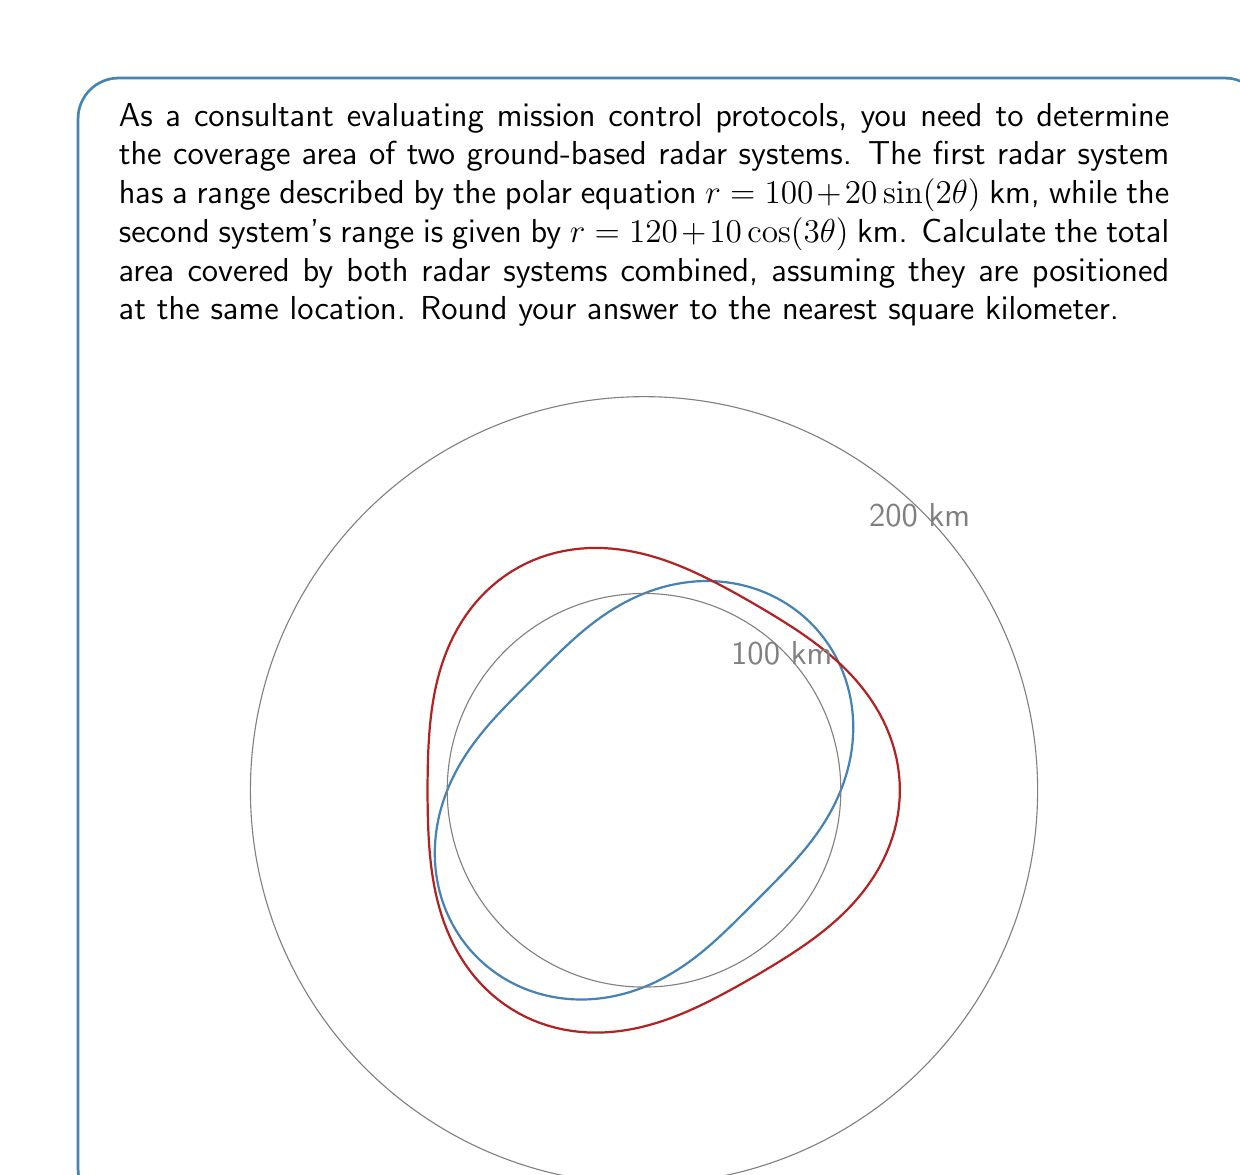Solve this math problem. To solve this problem, we need to calculate the areas of both radar systems and add them together. Let's break it down step-by-step:

1) For a polar equation $r = f(\theta)$, the area is given by the formula:

   $$A = \frac{1}{2} \int_0^{2\pi} [f(\theta)]^2 d\theta$$

2) For the first radar system: $r_1 = 100 + 20\sin(2\theta)$
   Area $A_1 = \frac{1}{2} \int_0^{2\pi} (100 + 20\sin(2\theta))^2 d\theta$

3) Expanding the integrand:
   $(100 + 20\sin(2\theta))^2 = 10000 + 4000\sin(2\theta) + 400\sin^2(2\theta)$

4) Using the identity $\sin^2(2\theta) = \frac{1}{2}(1 - \cos(4\theta))$, we get:
   $10000 + 4000\sin(2\theta) + 200 - 200\cos(4\theta)$

5) Now, $A_1 = \frac{1}{2} \int_0^{2\pi} (10200 + 4000\sin(2\theta) - 200\cos(4\theta)) d\theta$

6) Integrating:
   $A_1 = \frac{1}{2} [10200\theta - 2000\cos(2\theta) - 50\sin(4\theta)]_0^{2\pi} = 10200\pi \approx 32044.24$ km²

7) For the second radar system: $r_2 = 120 + 10\cos(3\theta)$
   Area $A_2 = \frac{1}{2} \int_0^{2\pi} (120 + 10\cos(3\theta))^2 d\theta$

8) Expanding and using $\cos^2(3\theta) = \frac{1}{2}(1 + \cos(6\theta))$:
   $A_2 = \frac{1}{2} \int_0^{2\pi} (14400 + 2400\cos(3\theta) + 50 + 50\cos(6\theta)) d\theta$

9) Integrating:
   $A_2 = \frac{1}{2} [14450\theta - 800\sin(3\theta) + \frac{25}{3}\sin(6\theta)]_0^{2\pi} = 14450\pi \approx 45384.63$ km²

10) The total area covered is $A_{\text{total}} = A_1 + A_2 = 10200\pi + 14450\pi = 24650\pi \approx 77428.87$ km²

11) Rounding to the nearest square kilometer: 77429 km²
Answer: 77429 km² 